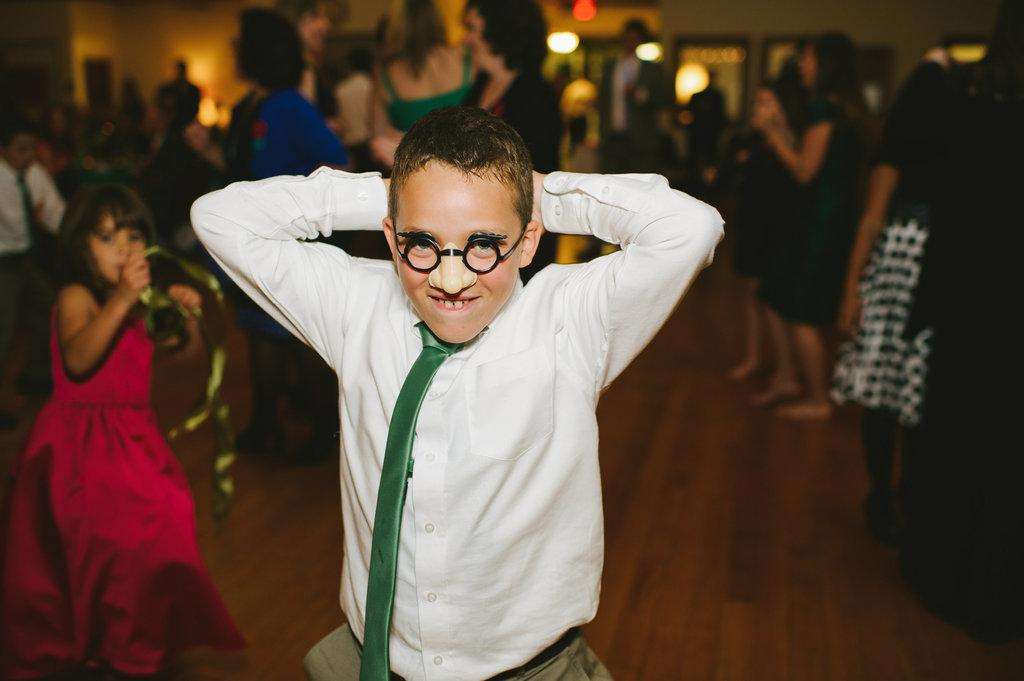What is the main subject in the foreground of the picture? There is a boy in the foreground of the picture. What is the boy doing in the image? The boy is dancing. How would you describe the background of the image? The background of the image is blurred. Can you describe the people in the background? There are people standing in the background, and some of them are dancing. What can be seen at the top of the image? There are lights visible at the top of the image. How far away is the gold glue from the boy in the image? There is no gold glue present in the image, so it cannot be determined how far away it might be from the boy. 